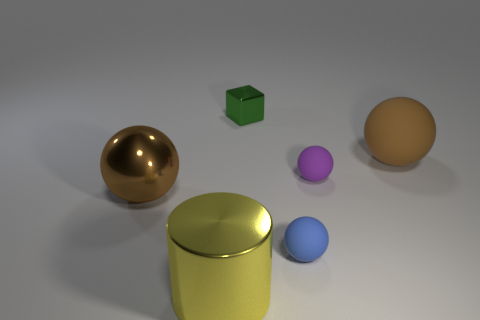Add 3 gray metallic balls. How many objects exist? 9 Subtract all cubes. How many objects are left? 5 Subtract 1 yellow cylinders. How many objects are left? 5 Subtract all tiny green objects. Subtract all tiny objects. How many objects are left? 2 Add 4 purple things. How many purple things are left? 5 Add 4 big matte balls. How many big matte balls exist? 5 